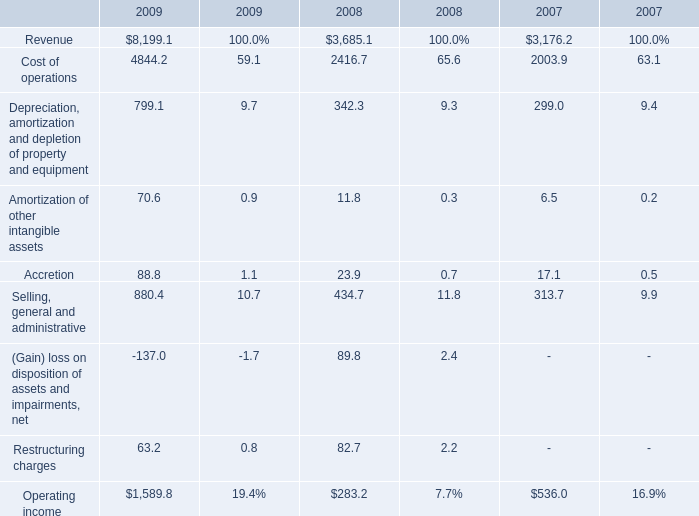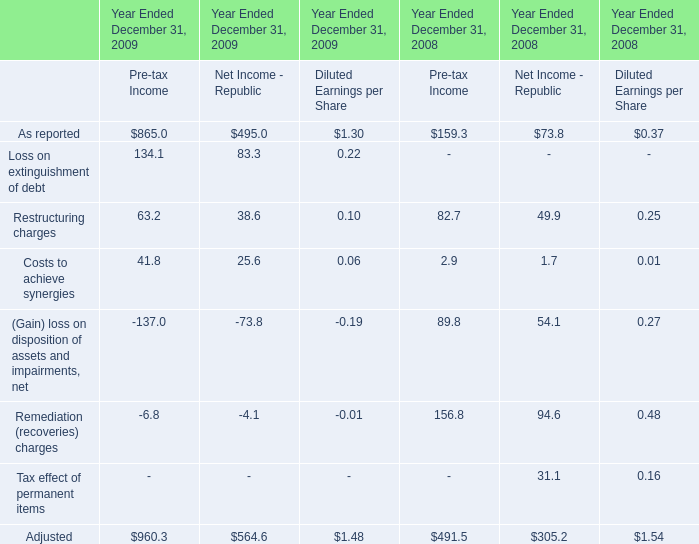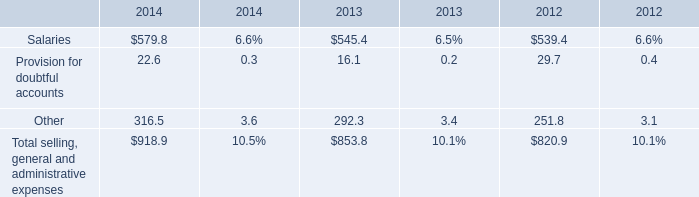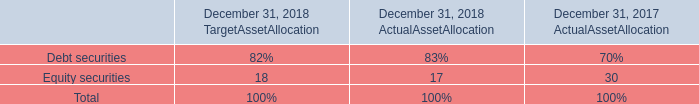In the year with the most Costs to achieve synergies of Pre-tax Income in Table 1, what is the growth rate of Accretion in Table 0? 
Computations: ((88.8 - 23.9) / 23.9)
Answer: 2.71548. 